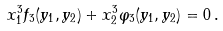Convert formula to latex. <formula><loc_0><loc_0><loc_500><loc_500>x _ { 1 } ^ { 3 } f _ { 3 } ( y _ { 1 } , y _ { 2 } ) + x _ { 2 } ^ { 3 } \varphi _ { 3 } ( y _ { 1 } , y _ { 2 } ) = 0 \, .</formula> 